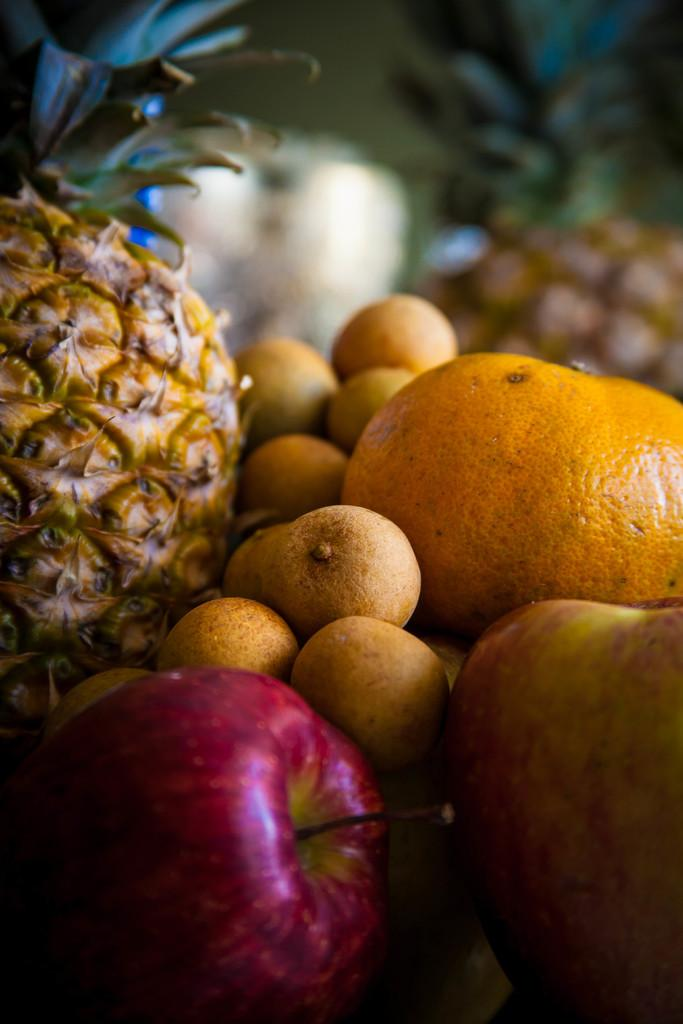What type of food can be seen in the image? There are fruits in the image. Can you name some specific fruits that are visible? The fruits include apples, oranges, and pineapples. What type of verse is being recited by the pineapple in the image? There is no pineapple reciting a verse in the image, as pineapples are not capable of speech or reciting verses. 